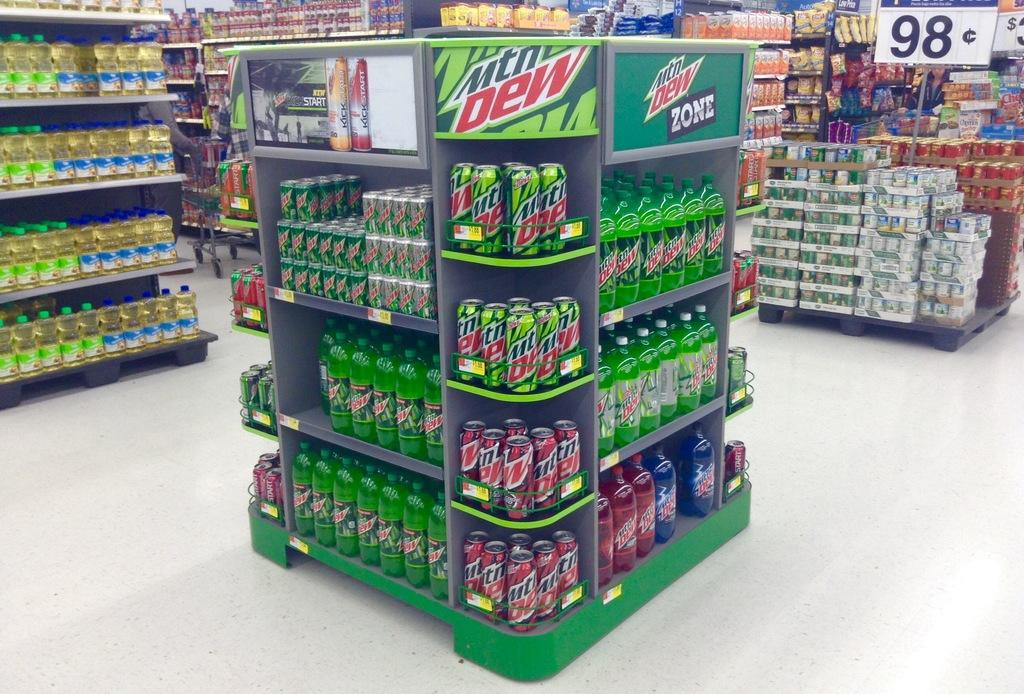<image>
Describe the image concisely. A display in the center of a story with many shelves full of various Mountain Dew products. 